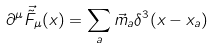Convert formula to latex. <formula><loc_0><loc_0><loc_500><loc_500>\partial ^ { \mu } \vec { \tilde { F } } _ { \mu } ( x ) = \sum _ { a } { \vec { m } } _ { a } \delta ^ { 3 } ( x - x _ { a } ) \quad</formula> 